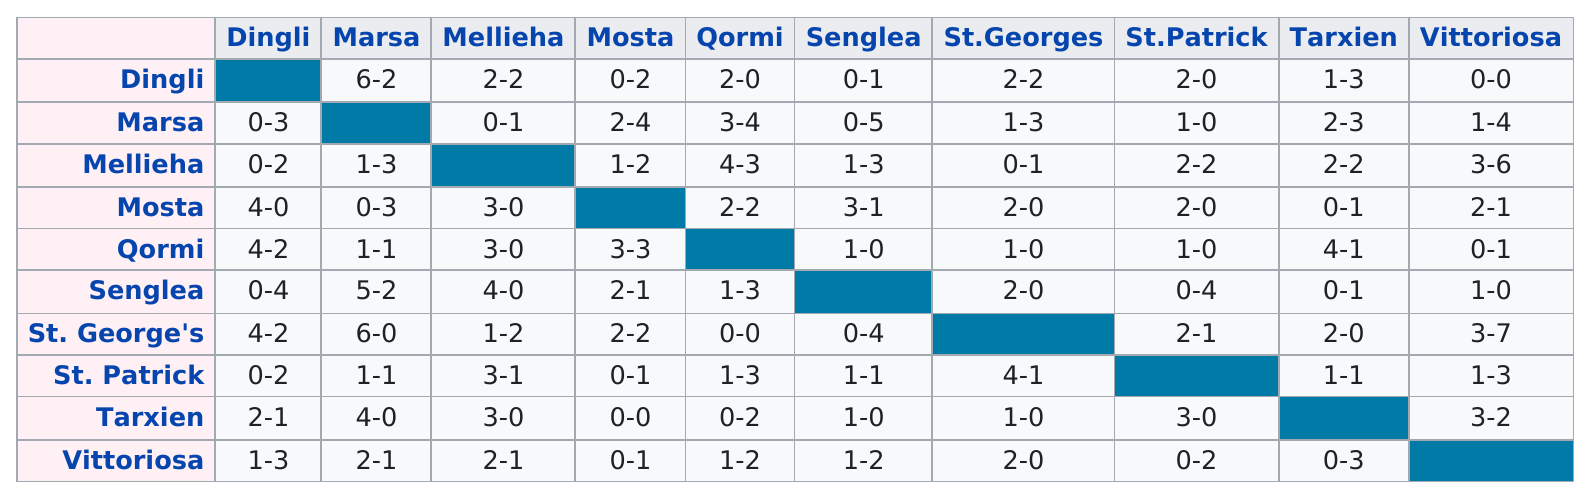Indicate a few pertinent items in this graphic. Tarxien won the most number of games among all teams. The total number of times Qormi won a game is 11. 